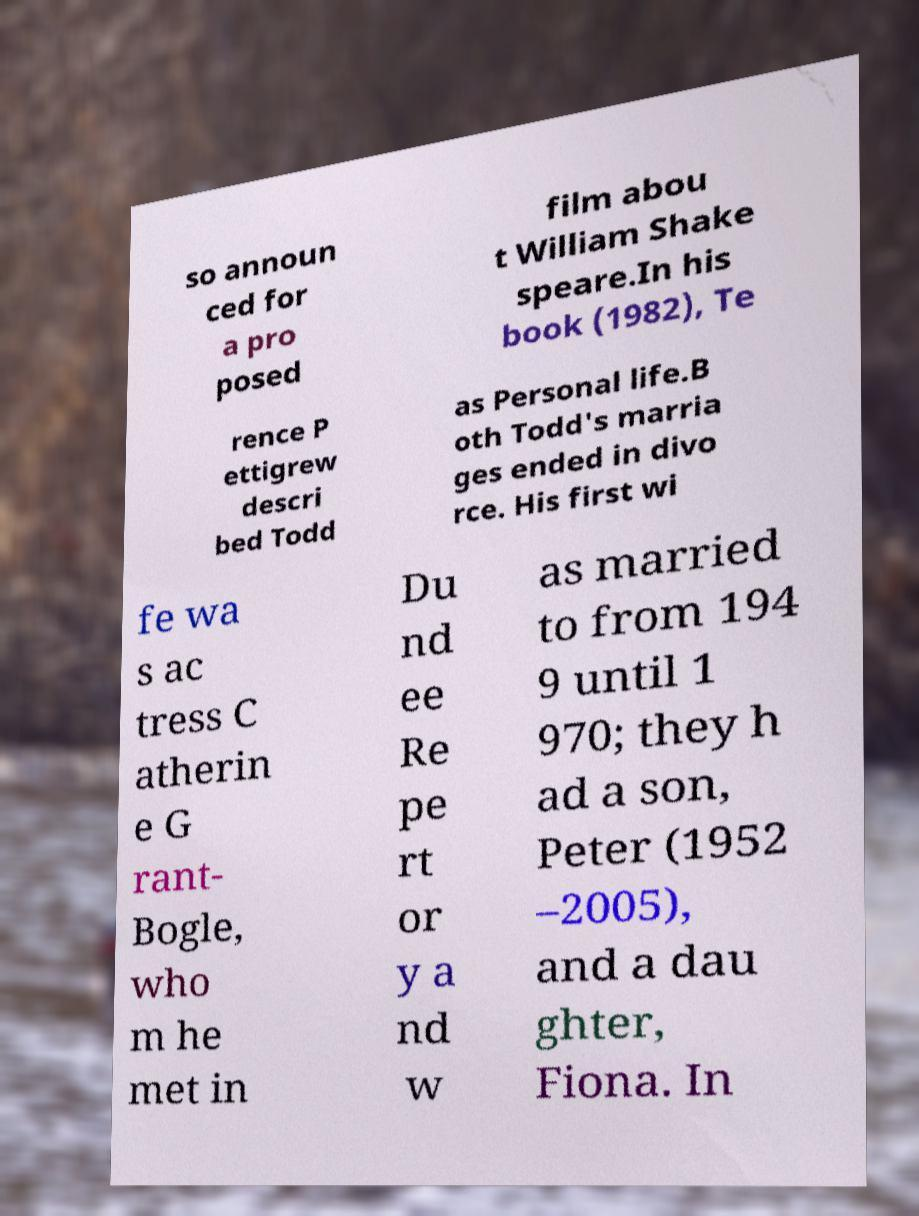Can you read and provide the text displayed in the image?This photo seems to have some interesting text. Can you extract and type it out for me? so announ ced for a pro posed film abou t William Shake speare.In his book (1982), Te rence P ettigrew descri bed Todd as Personal life.B oth Todd's marria ges ended in divo rce. His first wi fe wa s ac tress C atherin e G rant- Bogle, who m he met in Du nd ee Re pe rt or y a nd w as married to from 194 9 until 1 970; they h ad a son, Peter (1952 –2005), and a dau ghter, Fiona. In 